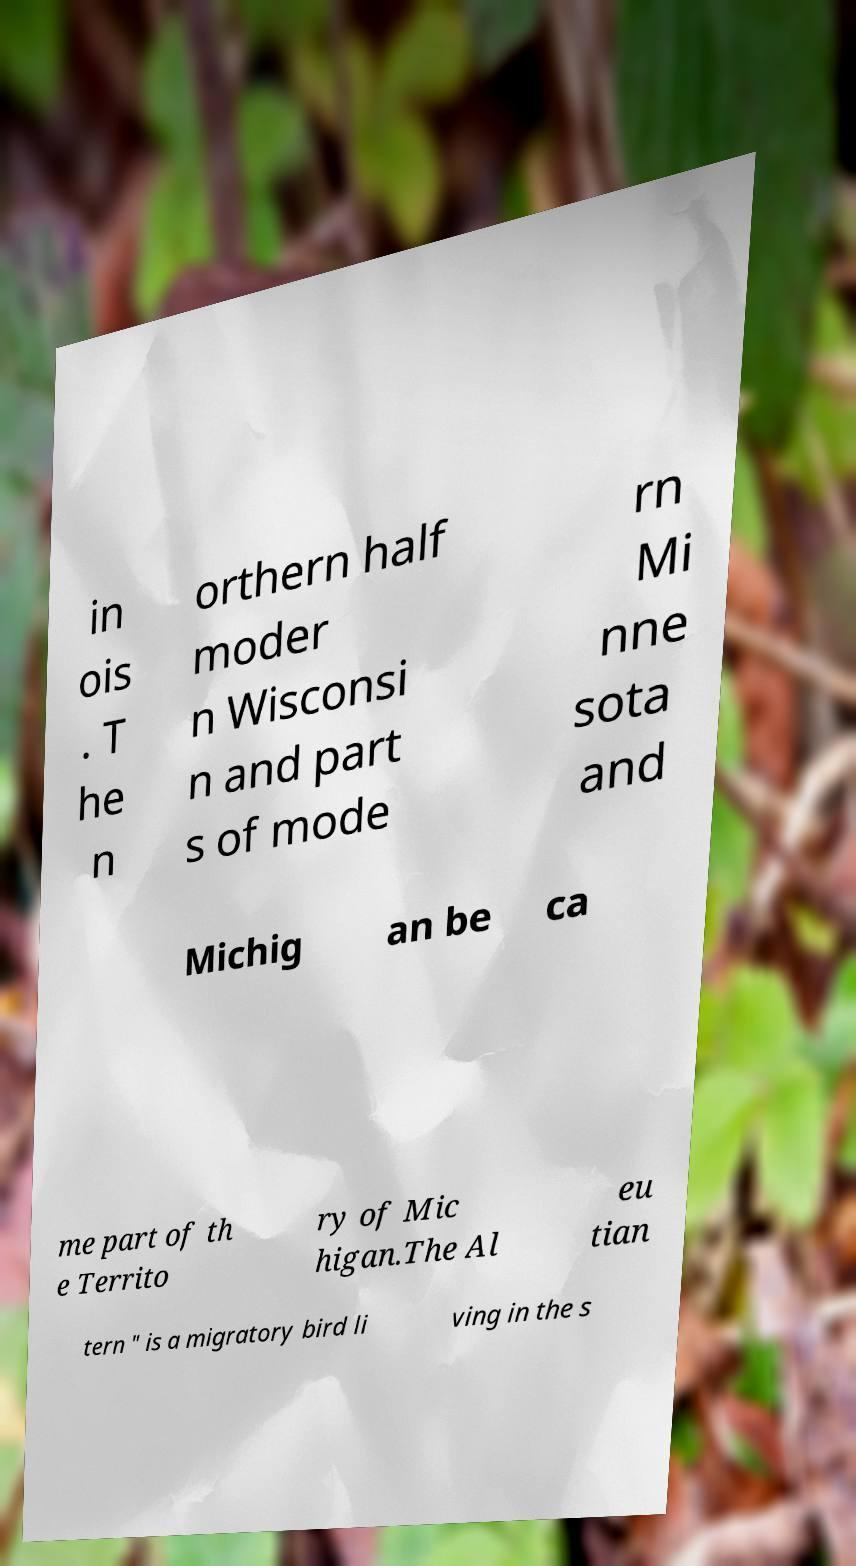For documentation purposes, I need the text within this image transcribed. Could you provide that? in ois . T he n orthern half moder n Wisconsi n and part s of mode rn Mi nne sota and Michig an be ca me part of th e Territo ry of Mic higan.The Al eu tian tern " is a migratory bird li ving in the s 